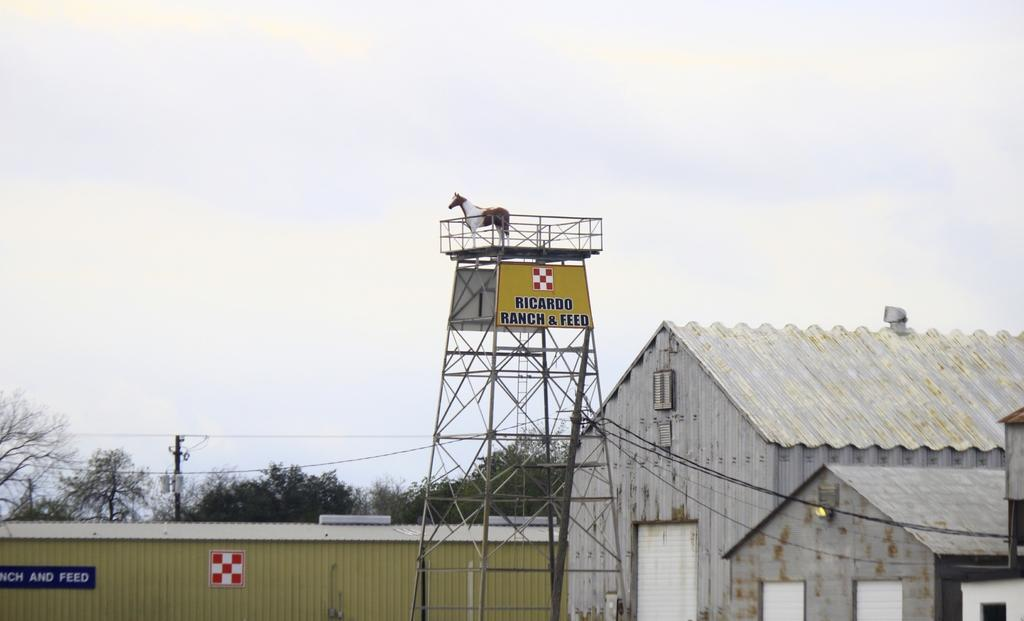What animal is on the tower in the image? There is a horse on a tower in the image. What type of objects can be seen in the image? There are boards, shutters, and sheds in the image. What type of vegetation is present in the image? There are trees in the image. What can be seen in the background of the image? The sky is visible in the background of the image. What type of jeans is the horse wearing in the image? There is no mention of jeans in the image, as it features a horse on a tower. 